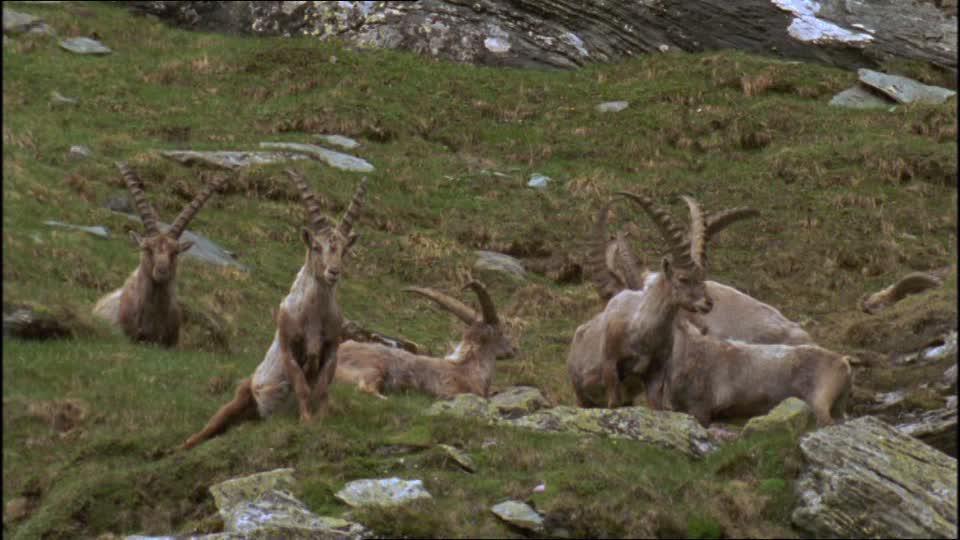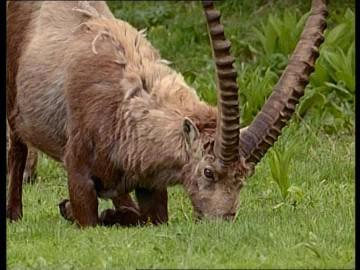The first image is the image on the left, the second image is the image on the right. Considering the images on both sides, is "A single horned animal is in a grassy area in one of the images." valid? Answer yes or no. Yes. The first image is the image on the left, the second image is the image on the right. Evaluate the accuracy of this statement regarding the images: "An image shows a single horned animal in a non-standing position.". Is it true? Answer yes or no. Yes. 